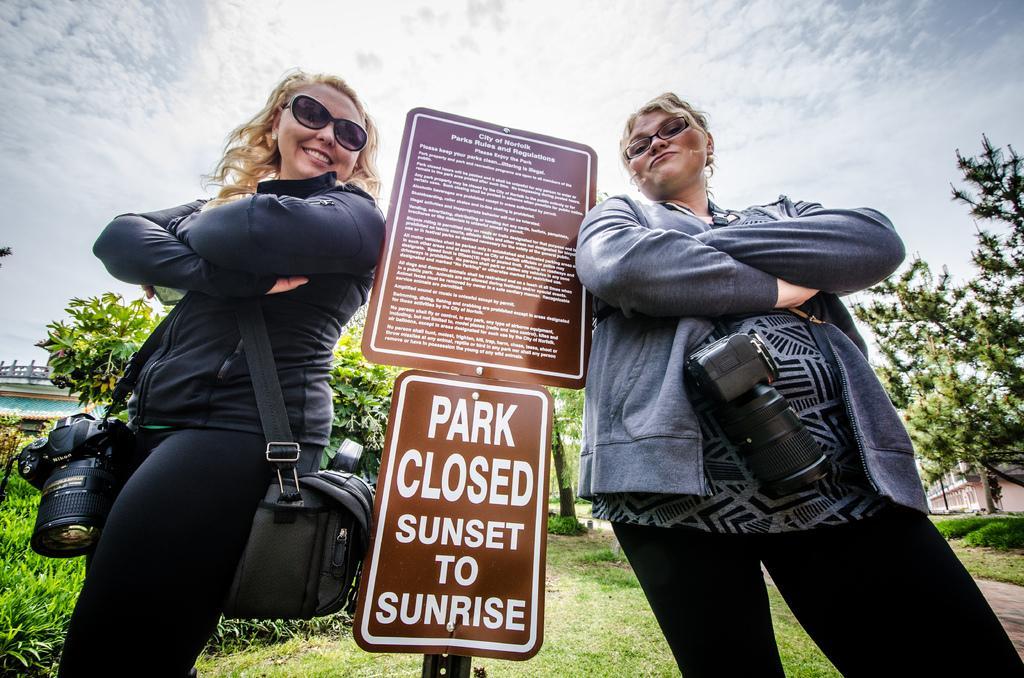In one or two sentences, can you explain what this image depicts? In this picture I can see there are two women standing and they are smiling, they are wearing glasses, there is a pole with boards and there is something written on it. There are plants at left side, there's grass on the floor, there is a building on the right side, there are trees and the sky is clear. 